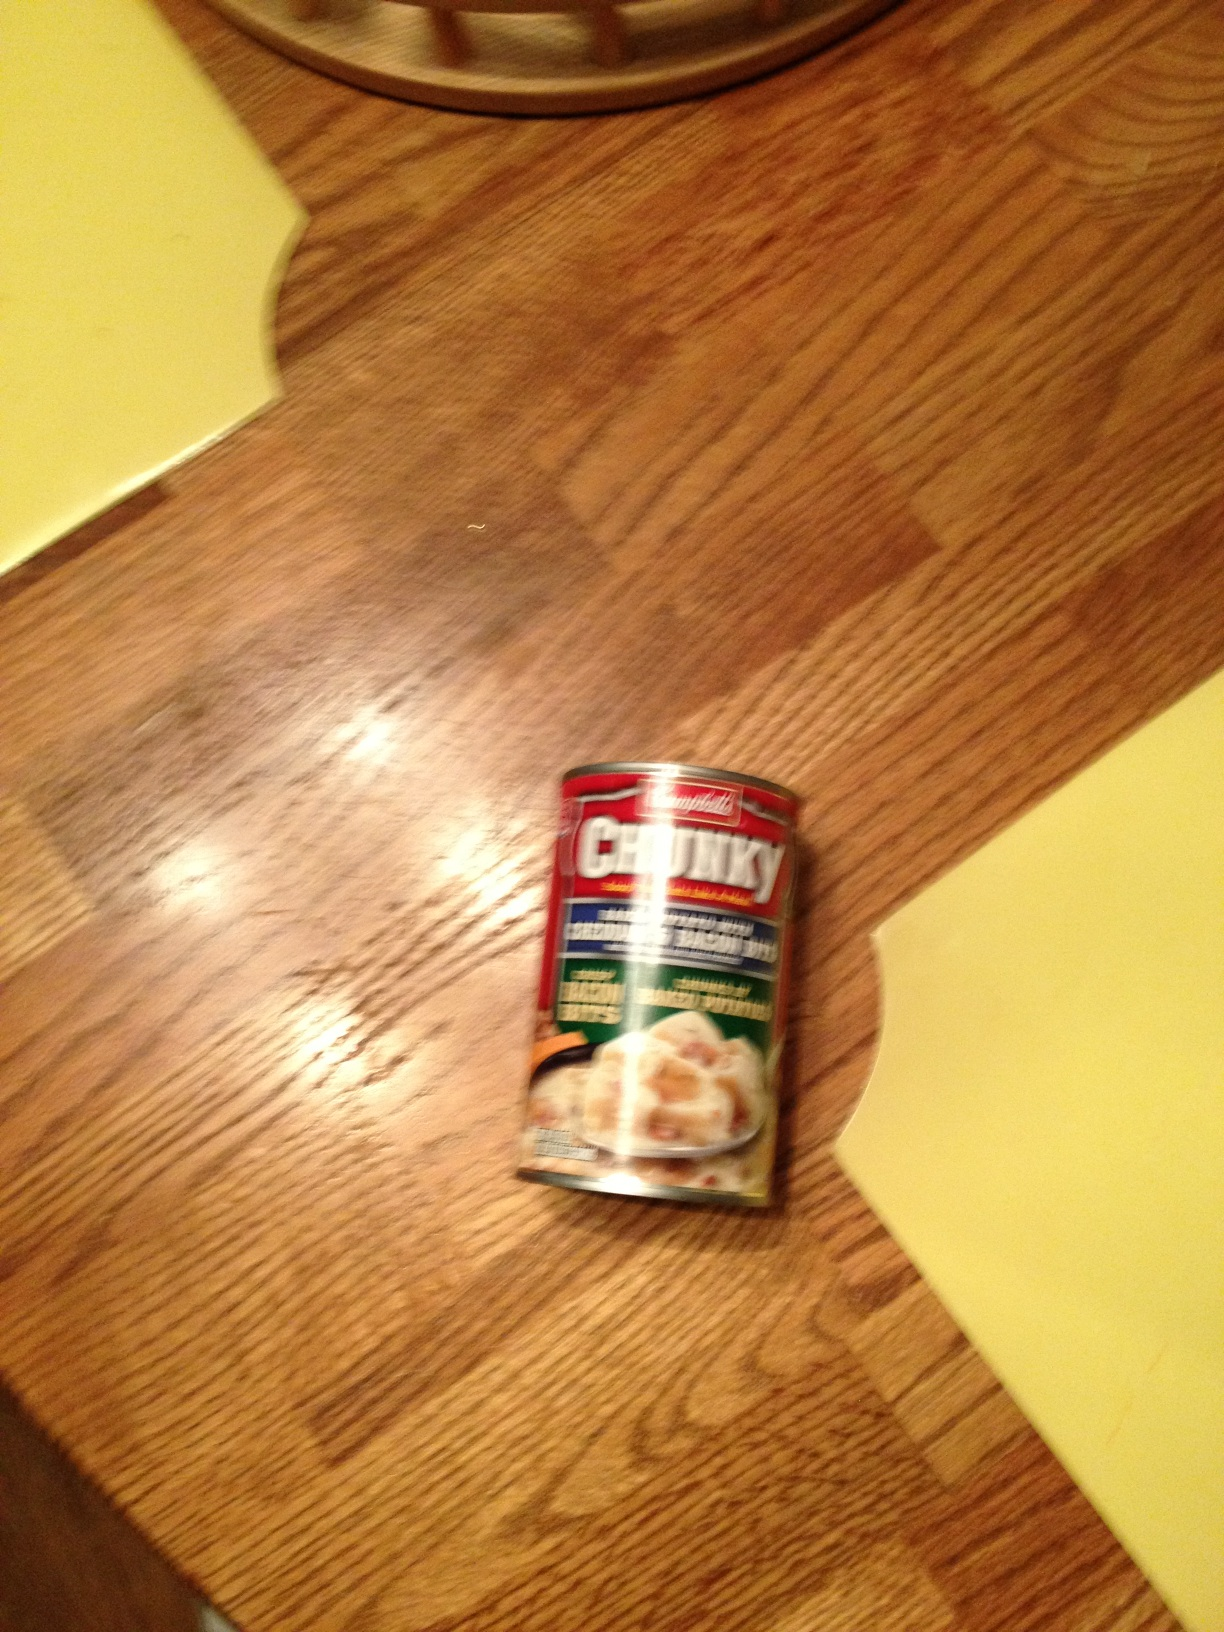Can you suggest a simple recipe that could be made using this type of canned soup? Certainly! You can create a quick chicken pot pie by pouring the Chunky chicken soup into a baking dish, covering it with a layer of pre-made pie crust, and baking it until the crust is golden brown. It's an easy and satisfying meal. 